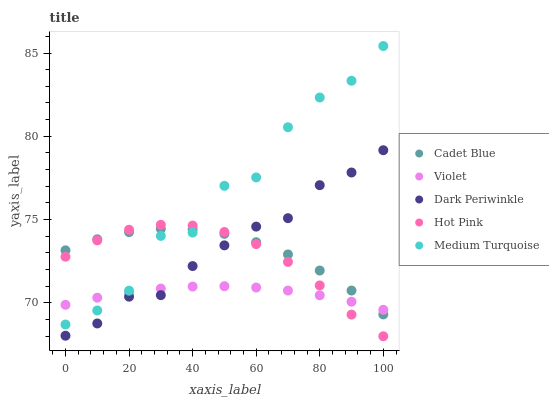Does Violet have the minimum area under the curve?
Answer yes or no. Yes. Does Medium Turquoise have the maximum area under the curve?
Answer yes or no. Yes. Does Cadet Blue have the minimum area under the curve?
Answer yes or no. No. Does Cadet Blue have the maximum area under the curve?
Answer yes or no. No. Is Violet the smoothest?
Answer yes or no. Yes. Is Medium Turquoise the roughest?
Answer yes or no. Yes. Is Cadet Blue the smoothest?
Answer yes or no. No. Is Cadet Blue the roughest?
Answer yes or no. No. Does Hot Pink have the lowest value?
Answer yes or no. Yes. Does Cadet Blue have the lowest value?
Answer yes or no. No. Does Medium Turquoise have the highest value?
Answer yes or no. Yes. Does Cadet Blue have the highest value?
Answer yes or no. No. Is Dark Periwinkle less than Medium Turquoise?
Answer yes or no. Yes. Is Medium Turquoise greater than Dark Periwinkle?
Answer yes or no. Yes. Does Violet intersect Dark Periwinkle?
Answer yes or no. Yes. Is Violet less than Dark Periwinkle?
Answer yes or no. No. Is Violet greater than Dark Periwinkle?
Answer yes or no. No. Does Dark Periwinkle intersect Medium Turquoise?
Answer yes or no. No. 